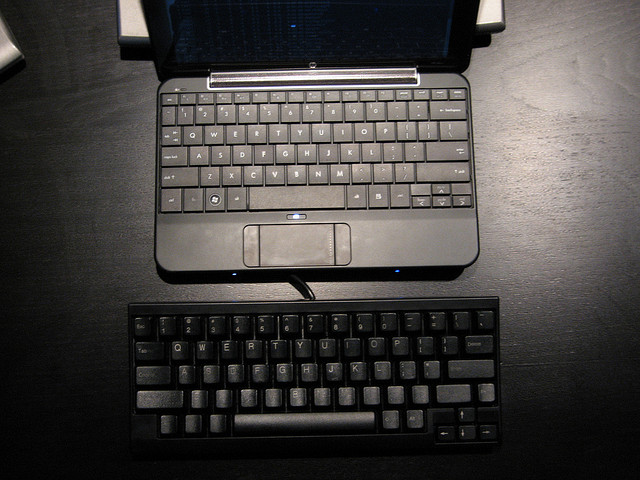Why are there two keyboards? I don't know why there are two keyboards. It can be for two computers or for improved functionality. Why are there two keyboards? I don't know why there are two keyboards. It could be for different purposes, such as improved functionality or for use with two computers. 